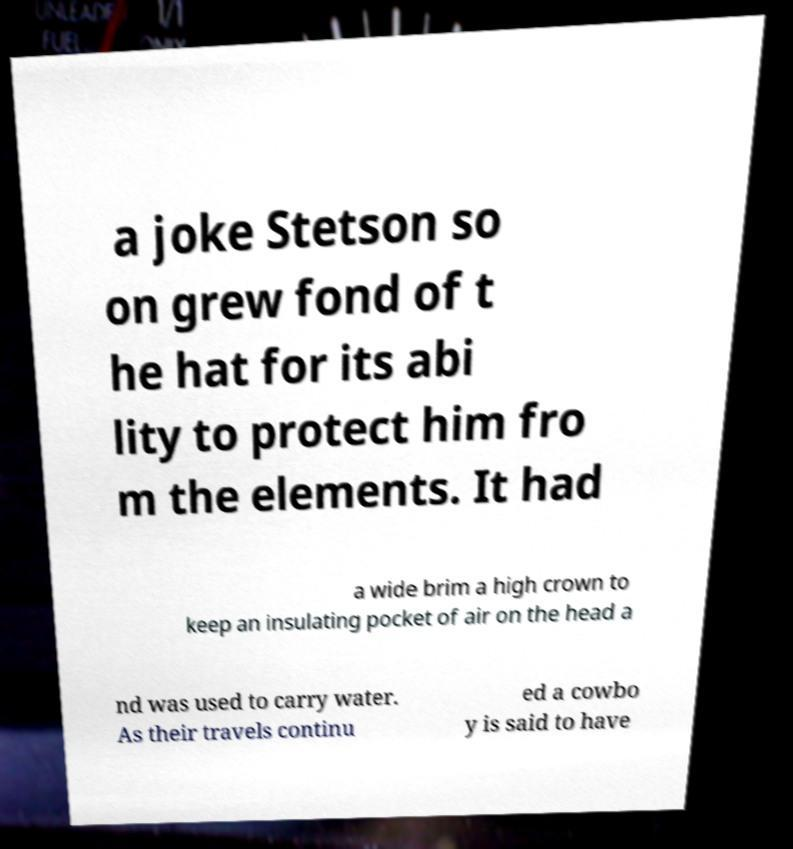Could you assist in decoding the text presented in this image and type it out clearly? a joke Stetson so on grew fond of t he hat for its abi lity to protect him fro m the elements. It had a wide brim a high crown to keep an insulating pocket of air on the head a nd was used to carry water. As their travels continu ed a cowbo y is said to have 